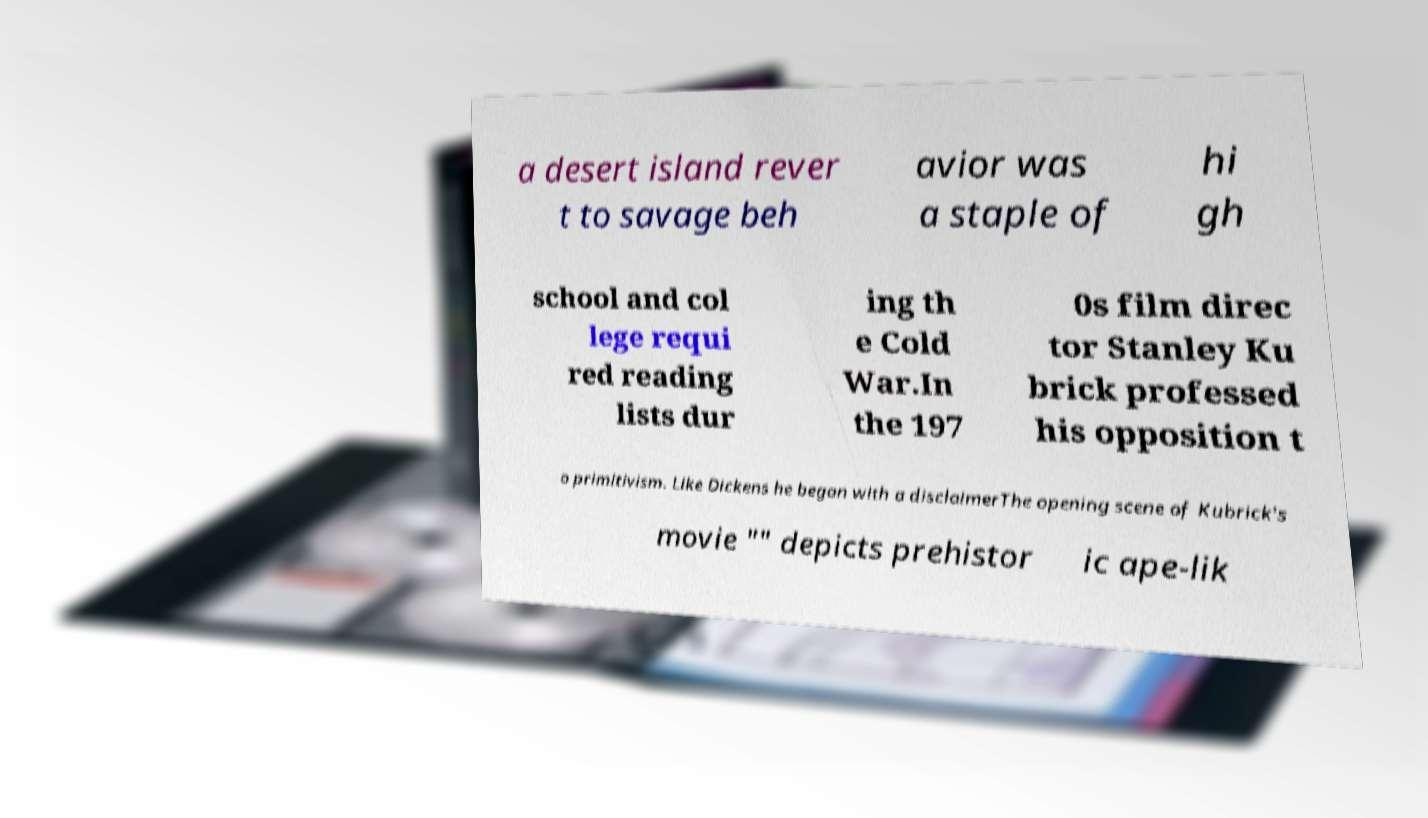For documentation purposes, I need the text within this image transcribed. Could you provide that? a desert island rever t to savage beh avior was a staple of hi gh school and col lege requi red reading lists dur ing th e Cold War.In the 197 0s film direc tor Stanley Ku brick professed his opposition t o primitivism. Like Dickens he began with a disclaimerThe opening scene of Kubrick's movie "" depicts prehistor ic ape-lik 